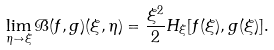Convert formula to latex. <formula><loc_0><loc_0><loc_500><loc_500>\lim _ { \eta \to \xi } \mathcal { B } ( f , g ) ( \xi , \eta ) = \frac { \xi ^ { 2 } } { 2 } H _ { \xi } [ f ( \xi ) , g ( \xi ) ] .</formula> 